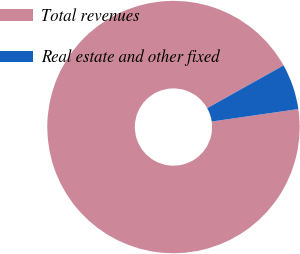<chart> <loc_0><loc_0><loc_500><loc_500><pie_chart><fcel>Total revenues<fcel>Real estate and other fixed<nl><fcel>94.16%<fcel>5.84%<nl></chart> 